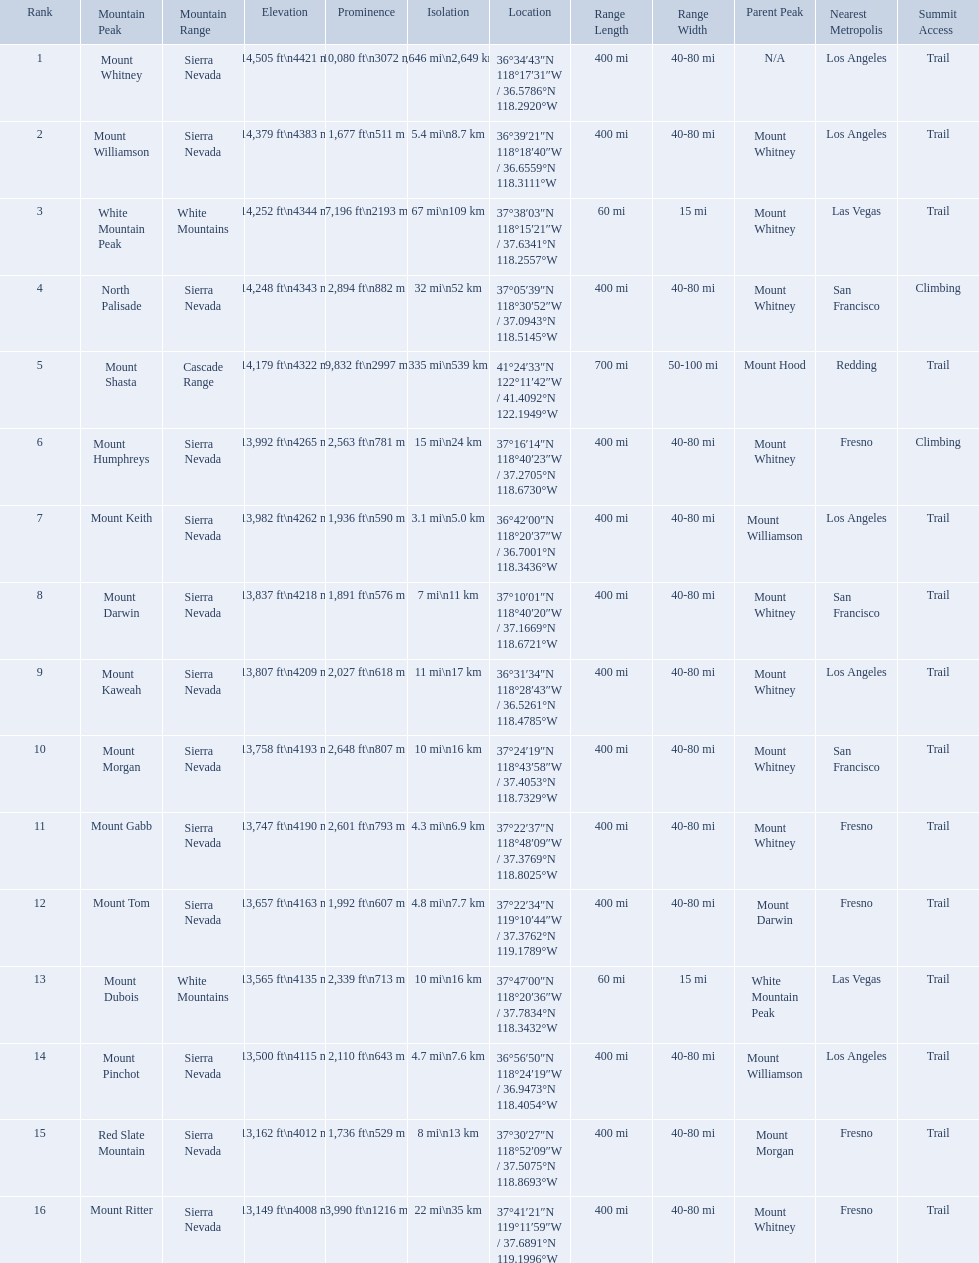Which are the mountain peaks? Mount Whitney, Mount Williamson, White Mountain Peak, North Palisade, Mount Shasta, Mount Humphreys, Mount Keith, Mount Darwin, Mount Kaweah, Mount Morgan, Mount Gabb, Mount Tom, Mount Dubois, Mount Pinchot, Red Slate Mountain, Mount Ritter. Of these, which is in the cascade range? Mount Shasta. Which mountain peaks have a prominence over 9,000 ft? Mount Whitney, Mount Shasta. Of those, which one has the the highest prominence? Mount Whitney. What are the listed elevations? 14,505 ft\n4421 m, 14,379 ft\n4383 m, 14,252 ft\n4344 m, 14,248 ft\n4343 m, 14,179 ft\n4322 m, 13,992 ft\n4265 m, 13,982 ft\n4262 m, 13,837 ft\n4218 m, 13,807 ft\n4209 m, 13,758 ft\n4193 m, 13,747 ft\n4190 m, 13,657 ft\n4163 m, 13,565 ft\n4135 m, 13,500 ft\n4115 m, 13,162 ft\n4012 m, 13,149 ft\n4008 m. Which of those is 13,149 ft or below? 13,149 ft\n4008 m. To what mountain peak does that value correspond? Mount Ritter. What are the heights of the peaks? 14,505 ft\n4421 m, 14,379 ft\n4383 m, 14,252 ft\n4344 m, 14,248 ft\n4343 m, 14,179 ft\n4322 m, 13,992 ft\n4265 m, 13,982 ft\n4262 m, 13,837 ft\n4218 m, 13,807 ft\n4209 m, 13,758 ft\n4193 m, 13,747 ft\n4190 m, 13,657 ft\n4163 m, 13,565 ft\n4135 m, 13,500 ft\n4115 m, 13,162 ft\n4012 m, 13,149 ft\n4008 m. Which of these heights is tallest? 14,505 ft\n4421 m. What peak is 14,505 feet? Mount Whitney. What are the peaks in california? Mount Whitney, Mount Williamson, White Mountain Peak, North Palisade, Mount Shasta, Mount Humphreys, Mount Keith, Mount Darwin, Mount Kaweah, Mount Morgan, Mount Gabb, Mount Tom, Mount Dubois, Mount Pinchot, Red Slate Mountain, Mount Ritter. What are the peaks in sierra nevada, california? Mount Whitney, Mount Williamson, North Palisade, Mount Humphreys, Mount Keith, Mount Darwin, Mount Kaweah, Mount Morgan, Mount Gabb, Mount Tom, Mount Pinchot, Red Slate Mountain, Mount Ritter. What are the heights of the peaks in sierra nevada? 14,505 ft\n4421 m, 14,379 ft\n4383 m, 14,248 ft\n4343 m, 13,992 ft\n4265 m, 13,982 ft\n4262 m, 13,837 ft\n4218 m, 13,807 ft\n4209 m, 13,758 ft\n4193 m, 13,747 ft\n4190 m, 13,657 ft\n4163 m, 13,500 ft\n4115 m, 13,162 ft\n4012 m, 13,149 ft\n4008 m. Which is the highest? Mount Whitney. What are all of the peaks? Mount Whitney, Mount Williamson, White Mountain Peak, North Palisade, Mount Shasta, Mount Humphreys, Mount Keith, Mount Darwin, Mount Kaweah, Mount Morgan, Mount Gabb, Mount Tom, Mount Dubois, Mount Pinchot, Red Slate Mountain, Mount Ritter. Where are they located? Sierra Nevada, Sierra Nevada, White Mountains, Sierra Nevada, Cascade Range, Sierra Nevada, Sierra Nevada, Sierra Nevada, Sierra Nevada, Sierra Nevada, Sierra Nevada, Sierra Nevada, White Mountains, Sierra Nevada, Sierra Nevada, Sierra Nevada. How tall are they? 14,505 ft\n4421 m, 14,379 ft\n4383 m, 14,252 ft\n4344 m, 14,248 ft\n4343 m, 14,179 ft\n4322 m, 13,992 ft\n4265 m, 13,982 ft\n4262 m, 13,837 ft\n4218 m, 13,807 ft\n4209 m, 13,758 ft\n4193 m, 13,747 ft\n4190 m, 13,657 ft\n4163 m, 13,565 ft\n4135 m, 13,500 ft\n4115 m, 13,162 ft\n4012 m, 13,149 ft\n4008 m. What about just the peaks in the sierra nevadas? 14,505 ft\n4421 m, 14,379 ft\n4383 m, 14,248 ft\n4343 m, 13,992 ft\n4265 m, 13,982 ft\n4262 m, 13,837 ft\n4218 m, 13,807 ft\n4209 m, 13,758 ft\n4193 m, 13,747 ft\n4190 m, 13,657 ft\n4163 m, 13,500 ft\n4115 m, 13,162 ft\n4012 m, 13,149 ft\n4008 m. And of those, which is the tallest? Mount Whitney. Which are the highest mountain peaks in california? Mount Whitney, Mount Williamson, White Mountain Peak, North Palisade, Mount Shasta, Mount Humphreys, Mount Keith, Mount Darwin, Mount Kaweah, Mount Morgan, Mount Gabb, Mount Tom, Mount Dubois, Mount Pinchot, Red Slate Mountain, Mount Ritter. Of those, which are not in the sierra nevada range? White Mountain Peak, Mount Shasta, Mount Dubois. Of the mountains not in the sierra nevada range, which is the only mountain in the cascades? Mount Shasta. 